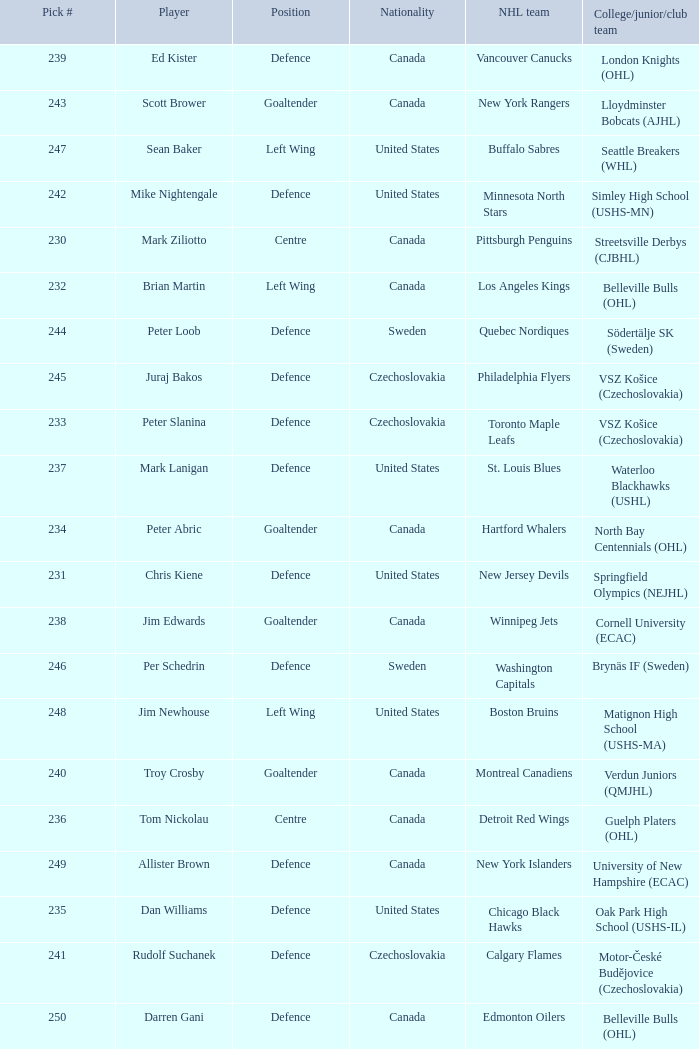Which draft number did the new jersey devils get? 231.0. Could you parse the entire table as a dict? {'header': ['Pick #', 'Player', 'Position', 'Nationality', 'NHL team', 'College/junior/club team'], 'rows': [['239', 'Ed Kister', 'Defence', 'Canada', 'Vancouver Canucks', 'London Knights (OHL)'], ['243', 'Scott Brower', 'Goaltender', 'Canada', 'New York Rangers', 'Lloydminster Bobcats (AJHL)'], ['247', 'Sean Baker', 'Left Wing', 'United States', 'Buffalo Sabres', 'Seattle Breakers (WHL)'], ['242', 'Mike Nightengale', 'Defence', 'United States', 'Minnesota North Stars', 'Simley High School (USHS-MN)'], ['230', 'Mark Ziliotto', 'Centre', 'Canada', 'Pittsburgh Penguins', 'Streetsville Derbys (CJBHL)'], ['232', 'Brian Martin', 'Left Wing', 'Canada', 'Los Angeles Kings', 'Belleville Bulls (OHL)'], ['244', 'Peter Loob', 'Defence', 'Sweden', 'Quebec Nordiques', 'Södertälje SK (Sweden)'], ['245', 'Juraj Bakos', 'Defence', 'Czechoslovakia', 'Philadelphia Flyers', 'VSZ Košice (Czechoslovakia)'], ['233', 'Peter Slanina', 'Defence', 'Czechoslovakia', 'Toronto Maple Leafs', 'VSZ Košice (Czechoslovakia)'], ['237', 'Mark Lanigan', 'Defence', 'United States', 'St. Louis Blues', 'Waterloo Blackhawks (USHL)'], ['234', 'Peter Abric', 'Goaltender', 'Canada', 'Hartford Whalers', 'North Bay Centennials (OHL)'], ['231', 'Chris Kiene', 'Defence', 'United States', 'New Jersey Devils', 'Springfield Olympics (NEJHL)'], ['238', 'Jim Edwards', 'Goaltender', 'Canada', 'Winnipeg Jets', 'Cornell University (ECAC)'], ['246', 'Per Schedrin', 'Defence', 'Sweden', 'Washington Capitals', 'Brynäs IF (Sweden)'], ['248', 'Jim Newhouse', 'Left Wing', 'United States', 'Boston Bruins', 'Matignon High School (USHS-MA)'], ['240', 'Troy Crosby', 'Goaltender', 'Canada', 'Montreal Canadiens', 'Verdun Juniors (QMJHL)'], ['236', 'Tom Nickolau', 'Centre', 'Canada', 'Detroit Red Wings', 'Guelph Platers (OHL)'], ['249', 'Allister Brown', 'Defence', 'Canada', 'New York Islanders', 'University of New Hampshire (ECAC)'], ['235', 'Dan Williams', 'Defence', 'United States', 'Chicago Black Hawks', 'Oak Park High School (USHS-IL)'], ['241', 'Rudolf Suchanek', 'Defence', 'Czechoslovakia', 'Calgary Flames', 'Motor-České Budějovice (Czechoslovakia)'], ['250', 'Darren Gani', 'Defence', 'Canada', 'Edmonton Oilers', 'Belleville Bulls (OHL)']]} 